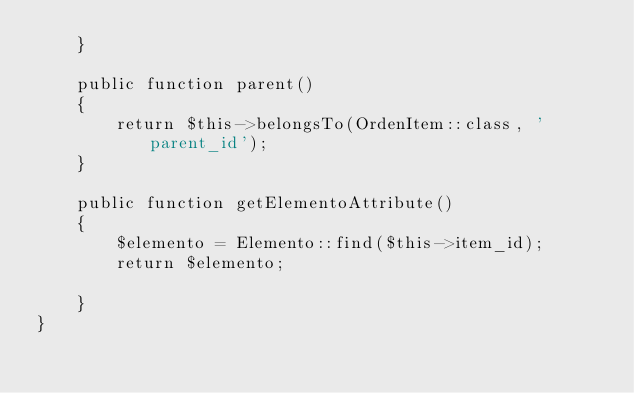Convert code to text. <code><loc_0><loc_0><loc_500><loc_500><_PHP_>    }

    public function parent()
    {
        return $this->belongsTo(OrdenItem::class, 'parent_id');
    }

    public function getElementoAttribute()
    {
        $elemento = Elemento::find($this->item_id);
        return $elemento;
        
    }
}
</code> 